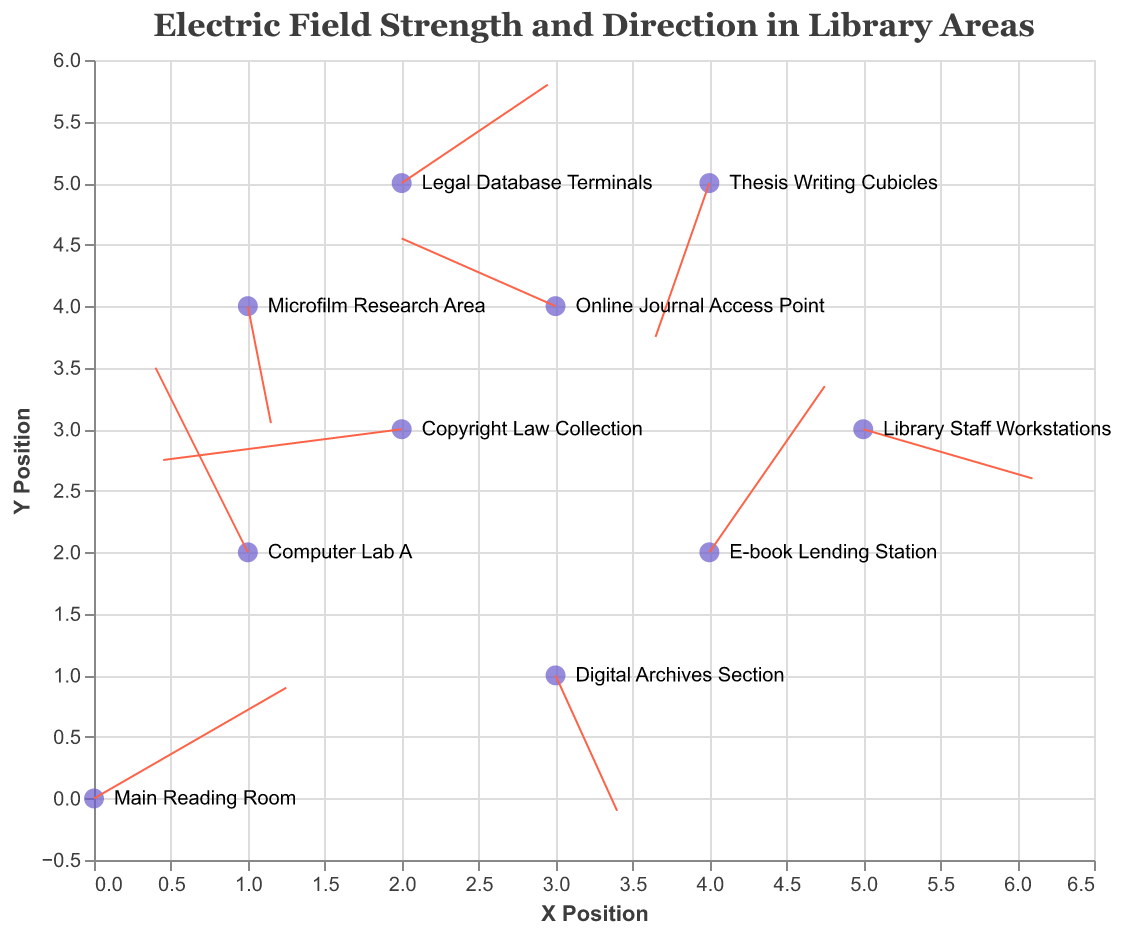What's the title of the plot? The title of the plot is displayed at the top, which reads "Electric Field Strength and Direction in Library Areas."
Answer: Electric Field Strength and Direction in Library Areas What is the color of the points representing the data locations? The color of the points representing the data locations is described as "#6A5ACD", which is a shade of purple.
Answer: purple How many data points are shown in the figure? To find the number of data points, count the individual points or locations represented on the plot.
Answer: 10 Which library area has the largest positive X component of the electric field? Look at the tooltip data for each library location to find the X component (u). The "Main Reading Room" has the highest positive value of 2.5.
Answer: Main Reading Room Which two areas have the electric field vectors pointing in approximately opposite directions? Notice the directions of the vectors by inspecting the (u, v) components. The vectors for the "Computer Lab A" (-1.2, 3.0) and "Copyright Law Collection" (-3.1, -0.5) are pointing in nearly opposite directions.
Answer: Computer Lab A and Copyright Law Collection Which location has the weakest overall electric field strength (smallest magnitude of the vector)? Calculate the magnitude of each vector using the formula sqrt(u^2 + v^2). The weakest magnitude is found at "Microfilm Research Area" with sqrt(0.3^2 + (-1.9)^2) ≈ 1.92.
Answer: Microfilm Research Area What is the vector direction at the "Library Staff Workstations"? The vector direction can be derived from the (u, v) values. For "Library Staff Workstations," the direction is given by the angle arctan(v/u), which corresponds to (2.2, -0.8).
Answer: to the right and slightly downward Between "E-book Lending Station" and "Thesis Writing Cubicles," which area has a stronger electric field and how can we tell? Compute the magnitudes for both vectors. For "E-book Lending Station," it is sqrt(1.5^2 + 2.7^2) ≈ 3.08. For "Thesis Writing Cubicles," it is sqrt((-0.7)^2 + (-2.5)^2) ≈ 2.60. Thus, "E-book Lending Station" has a stronger field.
Answer: E-book Lending Station Which area has an electric field vector with a negative Y component and a positive X component? Look for a vector where v < 0 and u > 0. The "Digital Archives Section" has such a vector with components (0.8, -2.2).
Answer: Digital Archives Section Calculate the average Y component of the electric field vectors for all the locations. Sum all the Y components (1.8 + 3.0 - 2.2 - 0.5 + 2.7 - 1.9 + 1.1 - 0.8 - 2.5 + 1.6) = 2.3 and then divide by the number of points (10), so the average is 2.3/10 = 0.23.
Answer: 0.23 